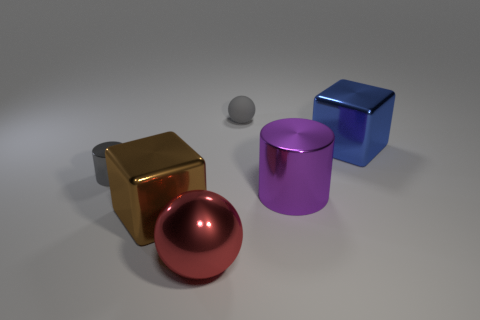What is the size of the matte ball that is the same color as the tiny cylinder?
Keep it short and to the point. Small. There is a small rubber ball; is it the same color as the shiny cylinder that is on the left side of the small rubber object?
Offer a terse response. Yes. Is the number of brown blocks less than the number of spheres?
Offer a very short reply. Yes. Do the tiny thing right of the large red metal object and the tiny cylinder have the same color?
Provide a succinct answer. Yes. What number of brown spheres have the same size as the rubber thing?
Keep it short and to the point. 0. Are there any small cylinders that have the same color as the small rubber ball?
Give a very brief answer. Yes. Is the material of the gray cylinder the same as the big blue cube?
Your answer should be compact. Yes. How many tiny gray metallic things are the same shape as the red object?
Your answer should be very brief. 0. What is the shape of the large purple object that is made of the same material as the gray cylinder?
Keep it short and to the point. Cylinder. What is the color of the block on the right side of the sphere behind the tiny cylinder?
Offer a terse response. Blue. 